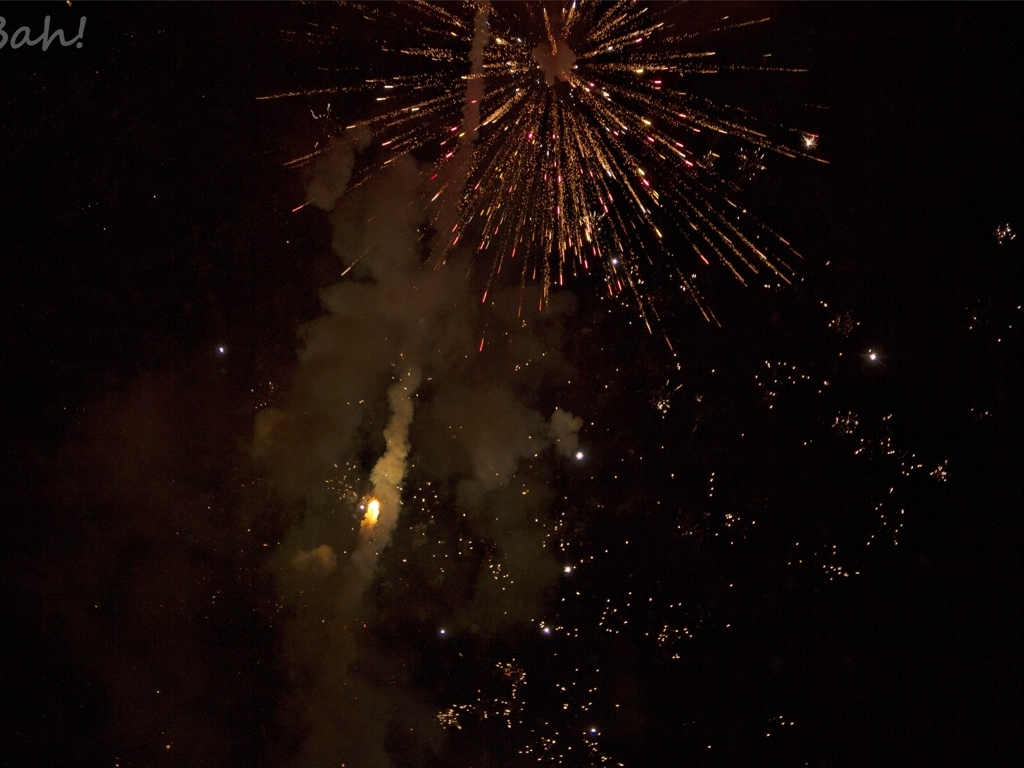Is there any blurriness in the image? The image is mostly clear with the central fireworks being in focus, though some areas, particularly around the edges and the points of light, might appear slightly blurred due to the movement and the nature of the fireworks' bright, transient light. 